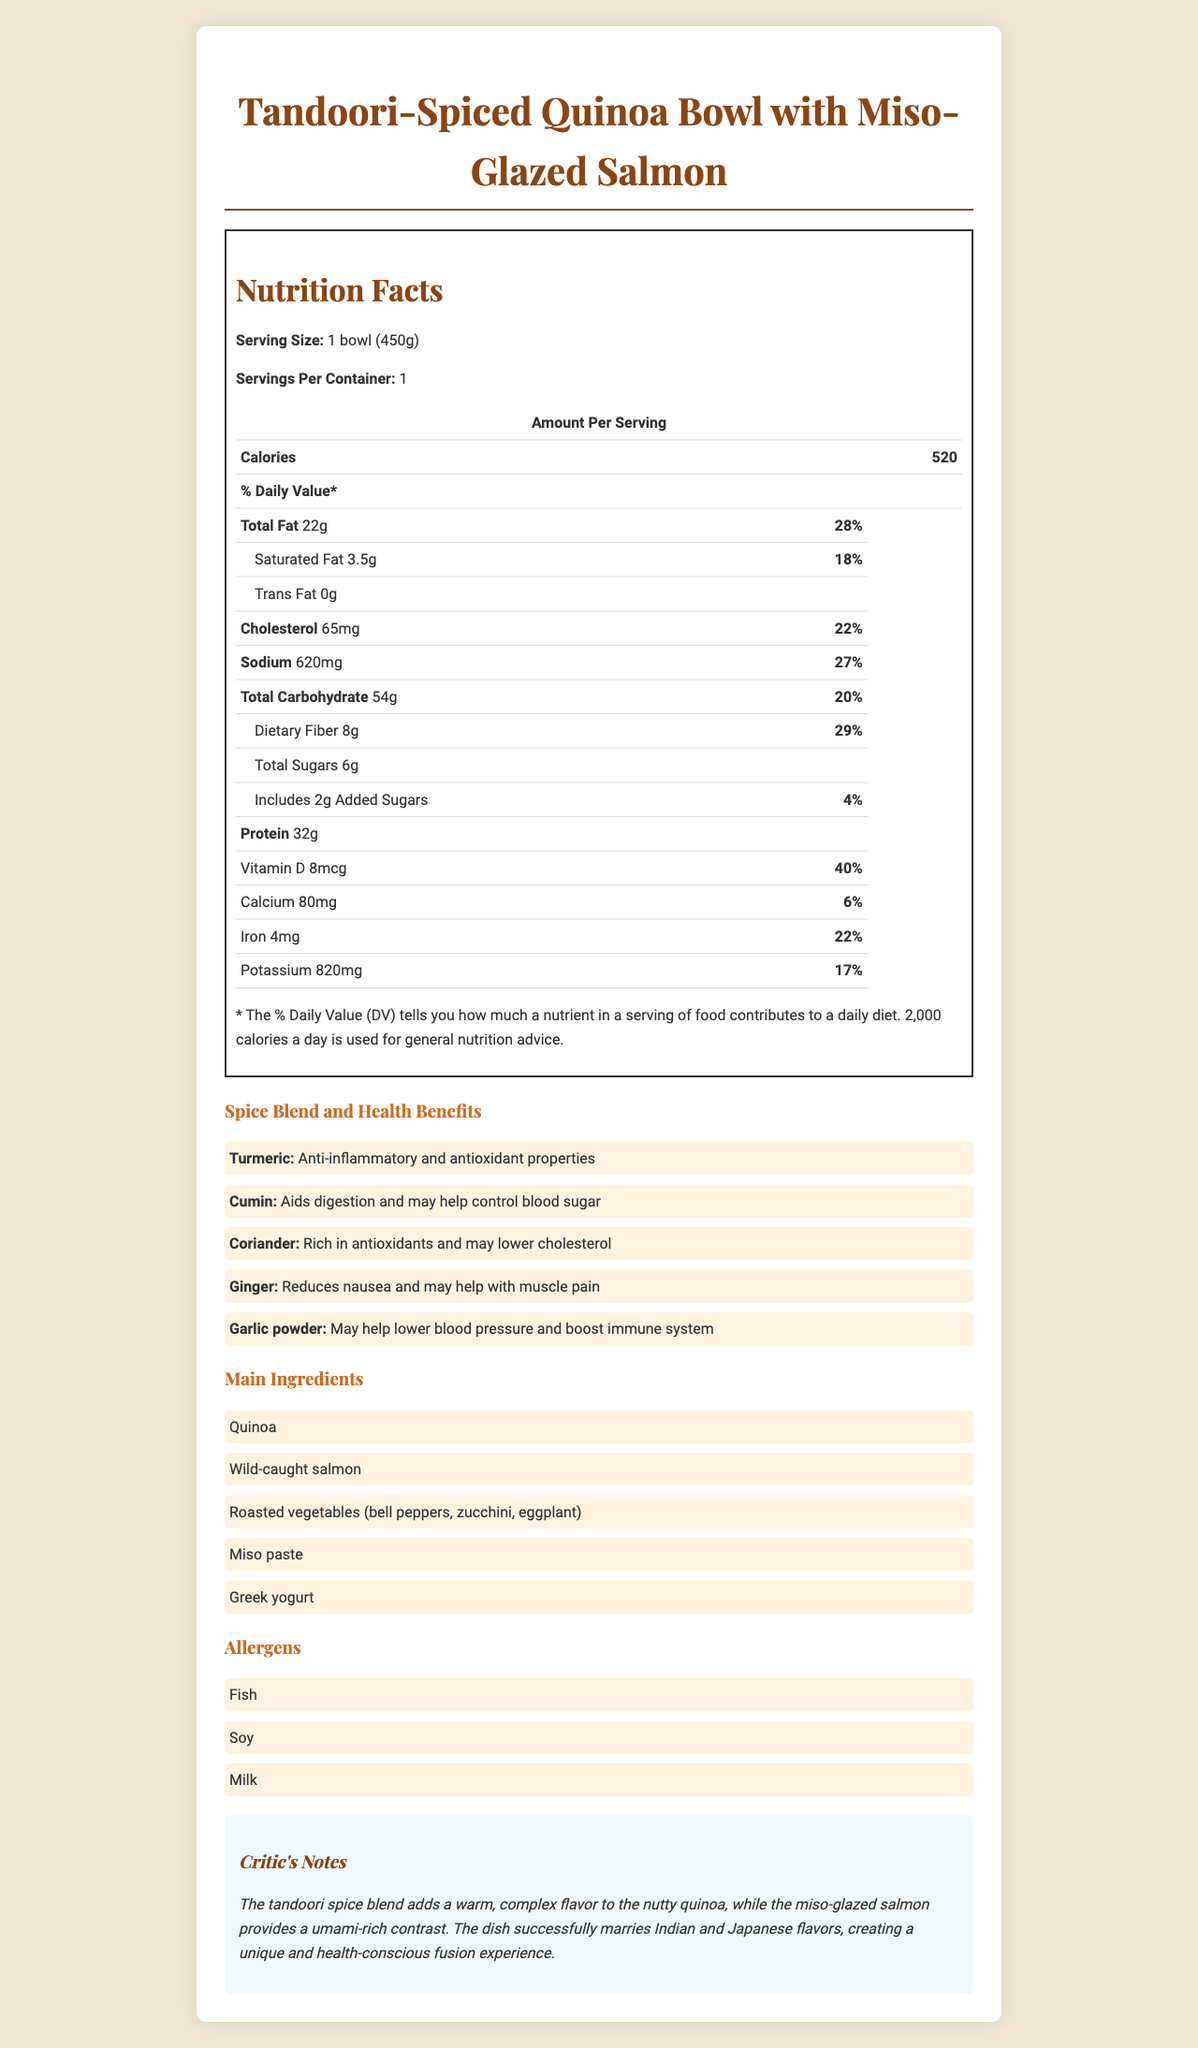what is the serving size of the dish? The serving size is mentioned in the Nutrition Facts section of the document as "1 bowl (450g)".
Answer: 1 bowl (450g) how many calories are in one serving of the "Tandoori-Spiced Quinoa Bowl with Miso-Glazed Salmon"? The Nutrition Facts section highlights that one serving of the dish contains 520 calories.
Answer: 520 which spice in the "Tandoori-Spiced Quinoa Bowl with Miso-Glazed Salmon" is known for its anti-inflammatory and antioxidant properties? The Spice Blend section lists Turmeric as having anti-inflammatory and antioxidant properties.
Answer: Turmeric what percentage of the daily value of Vitamin D does one serving of this dish provide? In the Nutrition Facts section, it is mentioned that Vitamin D contributes 40% of the daily value.
Answer: 40% which ingredient in the dish might pose an issue for someone with a fish allergy? The Allergens section lists "Fish" as one of the allergens, and the Main Ingredients section mentions "Wild-caught salmon."
Answer: Wild-caught salmon how is the "Tandoori-Spiced Quinoa Bowl with Miso-Glazed Salmon" prepared? A. Raw B. Fried C. Baked and pan-seared The Preparation Method section specifies that the dish is baked and pan-seared.
Answer: C what is the total fat content per serving, and what percentage of daily value does it constitute? A. 22g, 15% B. 18g, 24% C. 22g, 28% The Nutrition Facts section states that the Total Fat content is 22g and it makes up 28% of the daily value.
Answer: C which of the following spices is not included in the "Tandoori-Spiced Quinoa Bowl with Miso-Glazed Salmon"? A. Turmeric B. Cumin C. Paprika D. Ginger The Spice Blend section lists Turmeric, Cumin, and Ginger but does not mention Paprika.
Answer: C does the dish contain any added sugars? The Nutrition Facts section lists Added Sugars as 2g, which is 4% of the daily value.
Answer: Yes what are the main components of the dish? The Main Ingredients section provides this list of components.
Answer: Quinoa, Wild-caught salmon, Roasted vegetables (bell peppers, zucchini, eggplant), Miso paste, Greek yogurt does the dish contain any trans fat? The Nutrition Facts section clearly states that the Trans Fat content is 0g.
Answer: No summarize the information provided in the document. The document gives comprehensive insight into the dish's nutritional content, ingredients, allergens, cooking method, and critic's opinion.
Answer: The document describes the "Tandoori-Spiced Quinoa Bowl with Miso-Glazed Salmon," a fusion of Indian and Japanese cuisines. It includes detailed nutrition facts, highlighting its calorie count, fat, cholesterol, sodium, carbohydrates, protein, and various vitamins and minerals. The dish features a spice blend with unique health benefits, including turmeric, cumin, coriander, ginger, and garlic powder. Main ingredients are quinoa, wild-caught salmon, roasted vegetables, miso paste, and Greek yogurt. Allergens present include fish, soy, and milk. The preparation method involves baking and pan-searing. Critic notes praise the effective fusion of flavors and health-conscious approach. what is the exact potassium amount per serving? The Nutrition Facts section specifies the potassium content as 820mg per serving.
Answer: 820mg is this dish considered high in fiber? With 8g of dietary fiber amounting to 29% of the daily value, the dish is considered high in fiber.
Answer: Yes which spice in the dish is suggested to help with muscle pain? The Spice Blend section notes that Ginger may help with muscle pain.
Answer: Ginger are there any details provided about the origin of the ingredients? The document does not provide details about where the ingredients are sourced from or their origin.
Answer: Not enough information how does the critic describe the fusion of flavors in this dish? The Critic's Notes section provides this analysis of the flavor fusion in the dish.
Answer: The critic notes that the tandoori spice blend adds a warm, complex flavor to the nutty quinoa, and the miso-glazed salmon provides a umami-rich contrast, creating a unique and health-conscious fusion experience. 